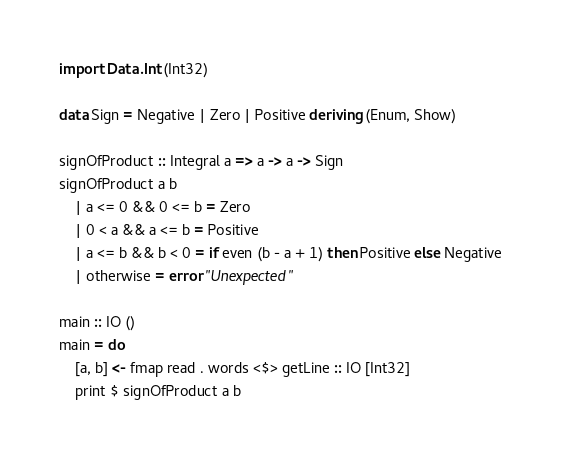Convert code to text. <code><loc_0><loc_0><loc_500><loc_500><_Haskell_>import Data.Int (Int32)

data Sign = Negative | Zero | Positive deriving (Enum, Show)

signOfProduct :: Integral a => a -> a -> Sign
signOfProduct a b
    | a <= 0 && 0 <= b = Zero
    | 0 < a && a <= b = Positive
    | a <= b && b < 0 = if even (b - a + 1) then Positive else Negative
    | otherwise = error "Unexpected"

main :: IO ()
main = do
    [a, b] <- fmap read . words <$> getLine :: IO [Int32]
    print $ signOfProduct a b
</code> 